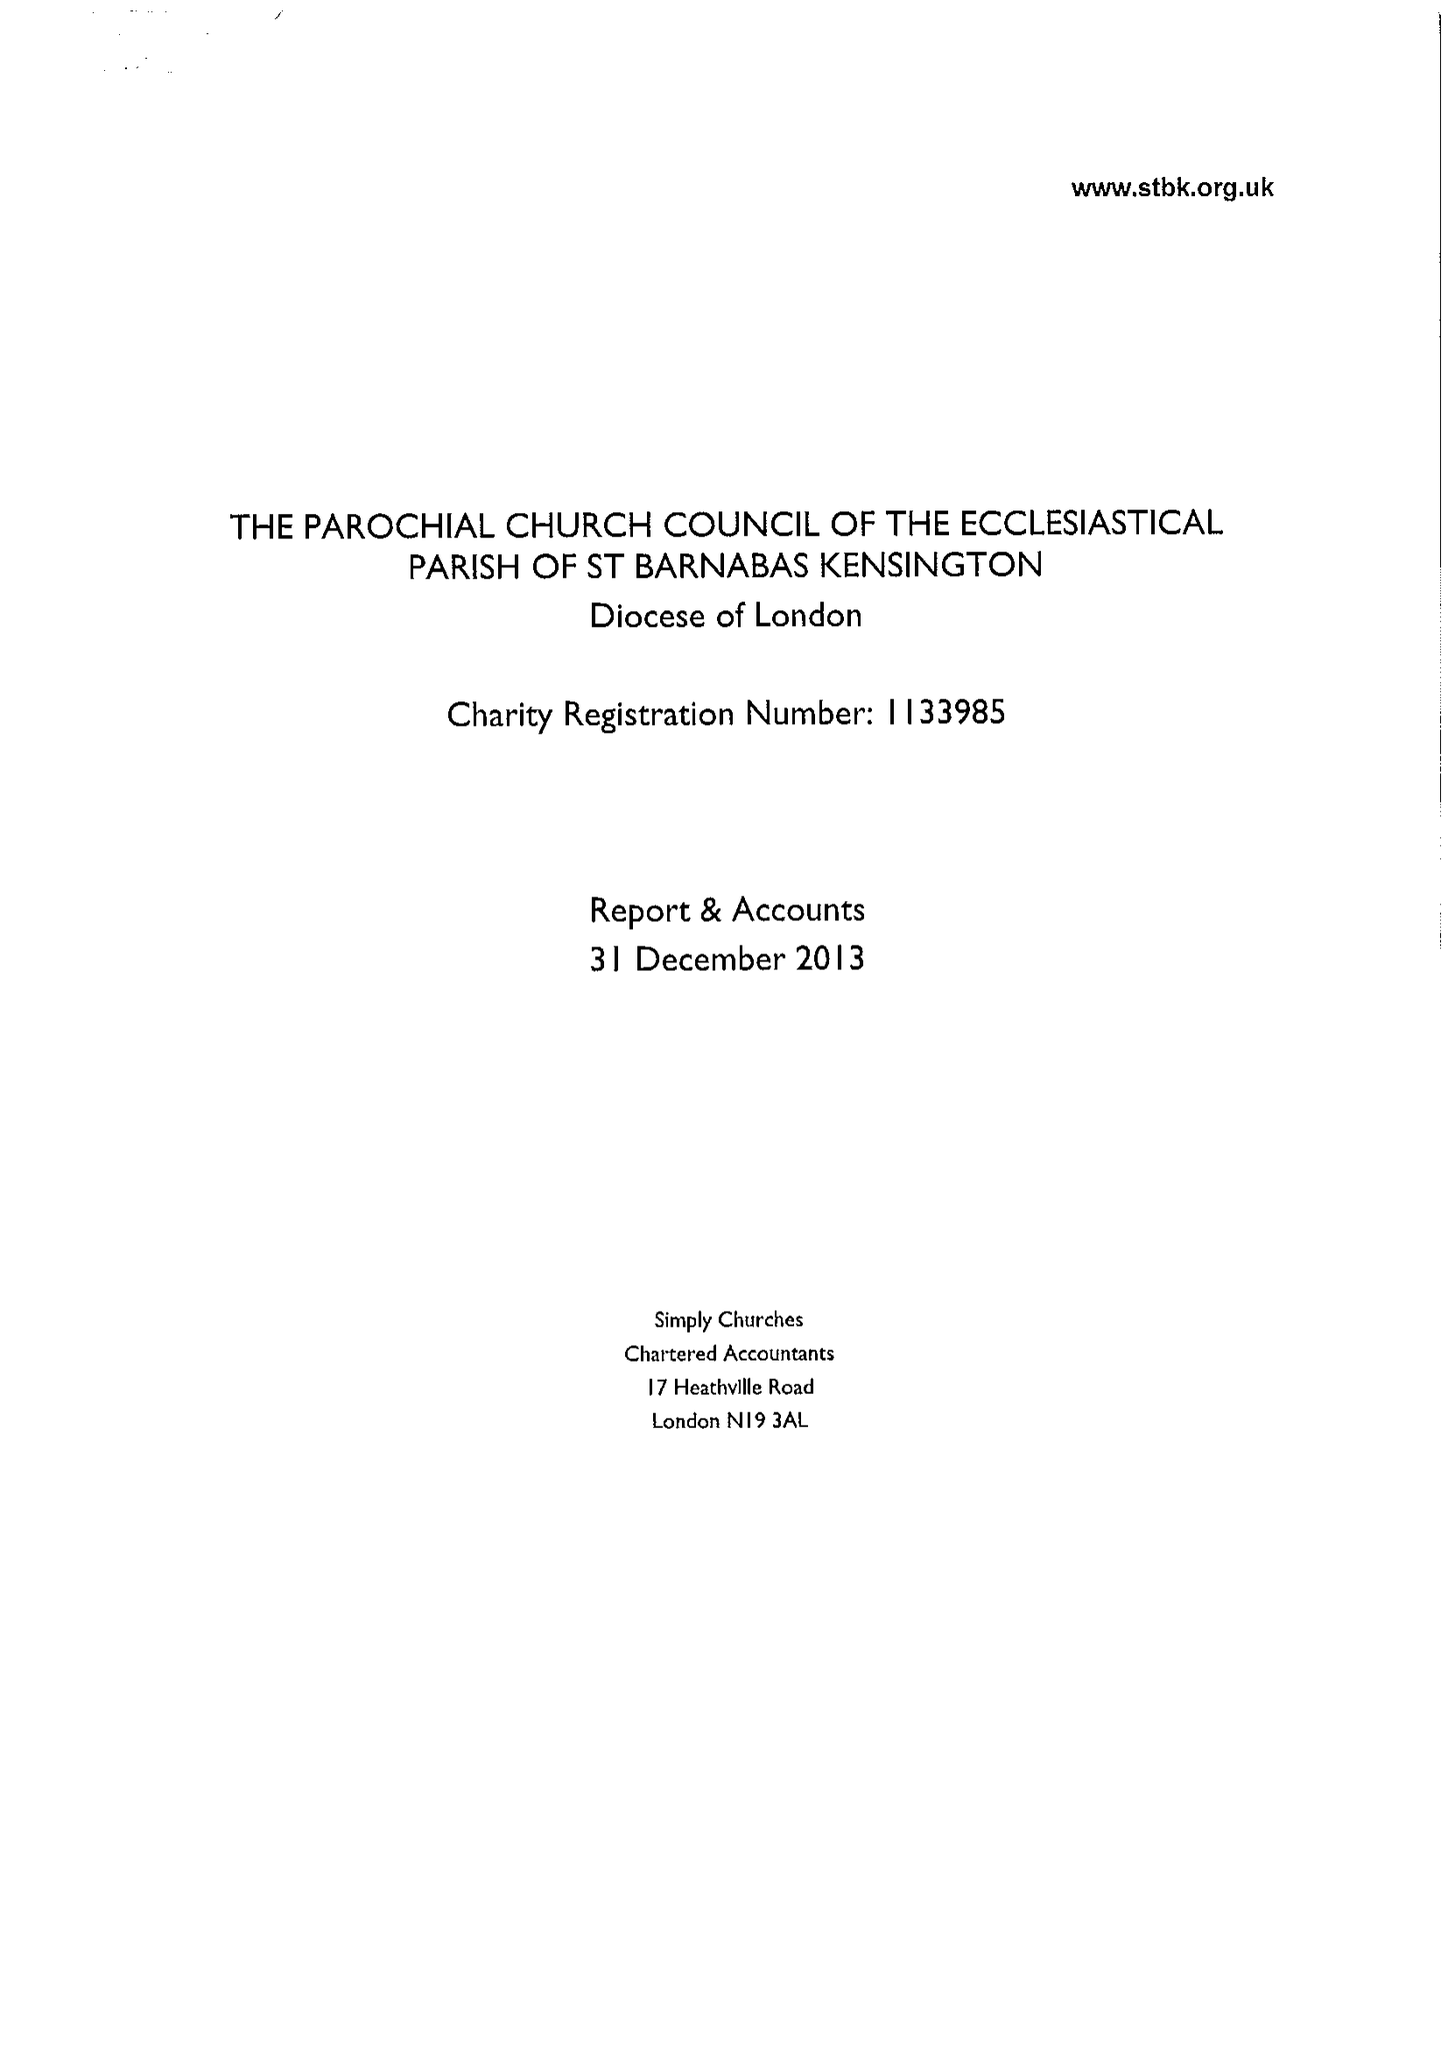What is the value for the report_date?
Answer the question using a single word or phrase. 2013-12-31 